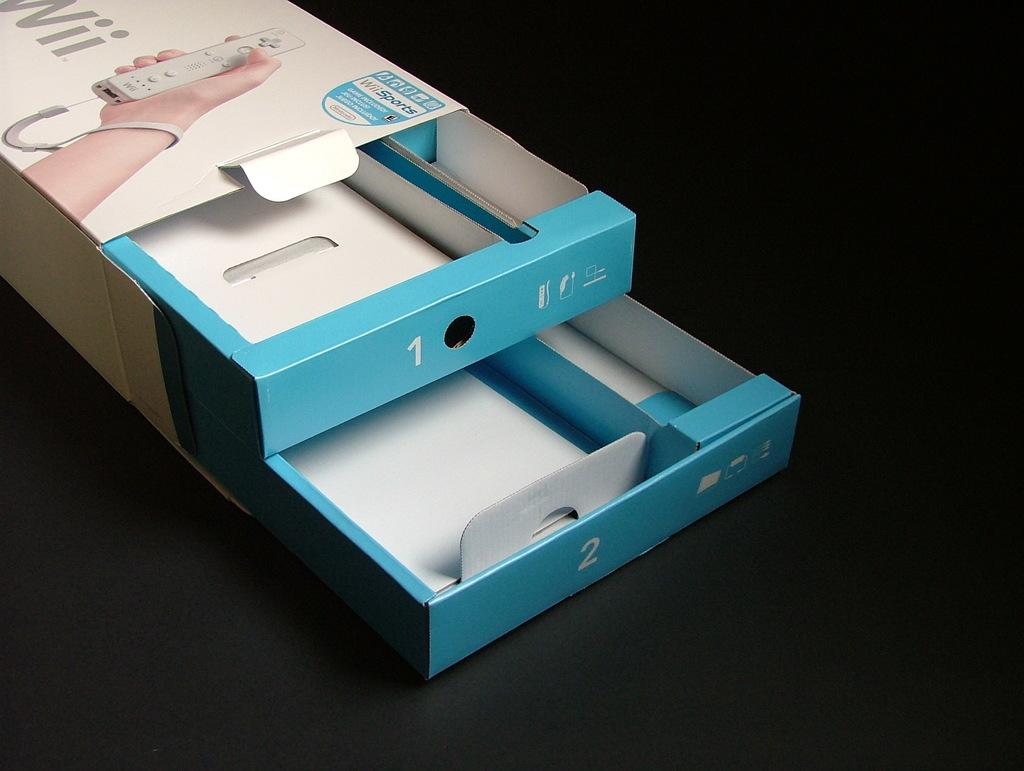What is inside the box in the image? The facts do not specify the contents of the box, so we cannot definitively answer this question. What object is being held by a hand in the image? A remote control is being held with a hand in the image. How would you describe the lighting in the image? The background of the image is dark. What type of leather material can be seen on the fan in the image? There is no fan present in the image, so we cannot answer this question. What type of thrill can be experienced while looking at the objects in the box? The image does not convey any sense of thrill, as it only shows a box and a remote control being held. 